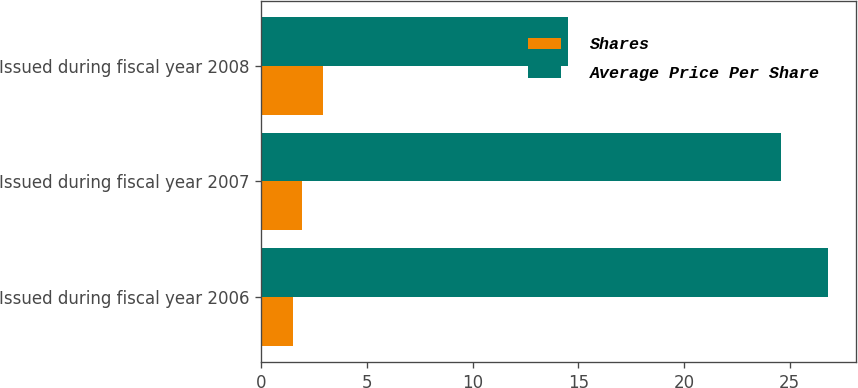Convert chart to OTSL. <chart><loc_0><loc_0><loc_500><loc_500><stacked_bar_chart><ecel><fcel>Issued during fiscal year 2006<fcel>Issued during fiscal year 2007<fcel>Issued during fiscal year 2008<nl><fcel>Shares<fcel>1.5<fcel>1.9<fcel>2.9<nl><fcel>Average Price Per Share<fcel>26.81<fcel>24.59<fcel>14.52<nl></chart> 